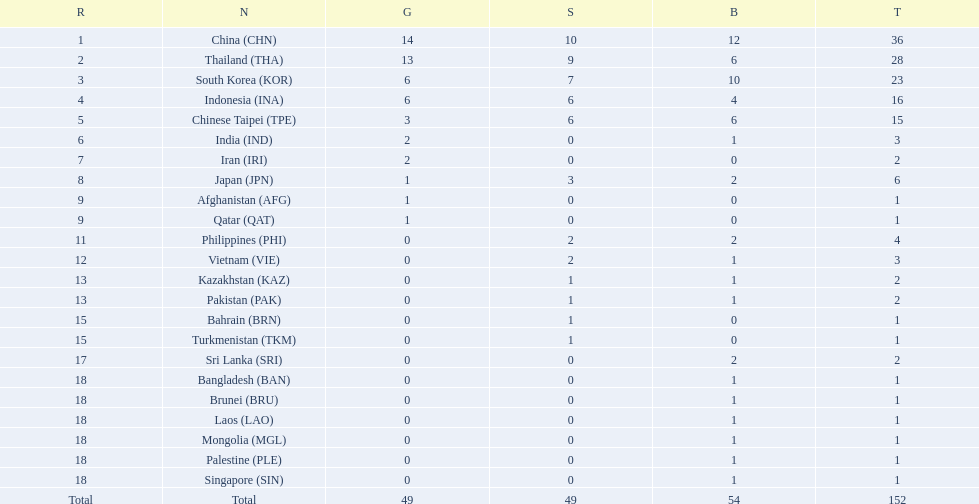How many combined silver medals did china, india, and japan earn ? 13. 